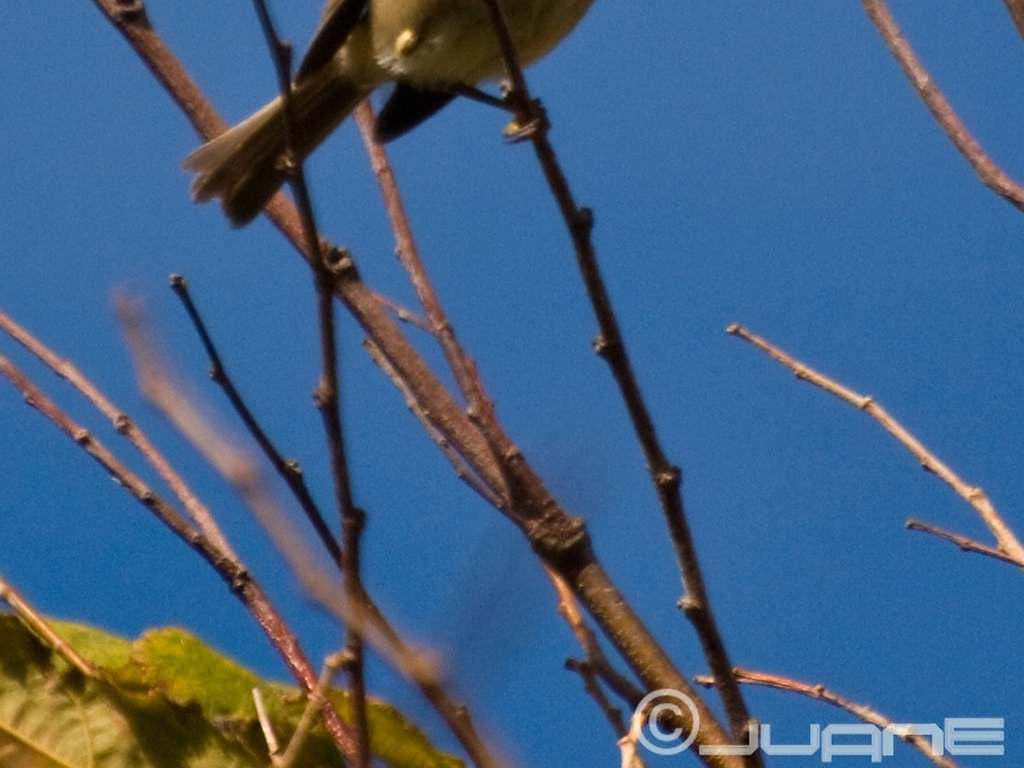Can you identify the type of environment where this photo might have been taken? Based on the blue sky in the background and the visible vegetation, this photo seems to have been taken outdoors, likely in a wooded or park area with open spaces that allow for a clear view of the sky. 